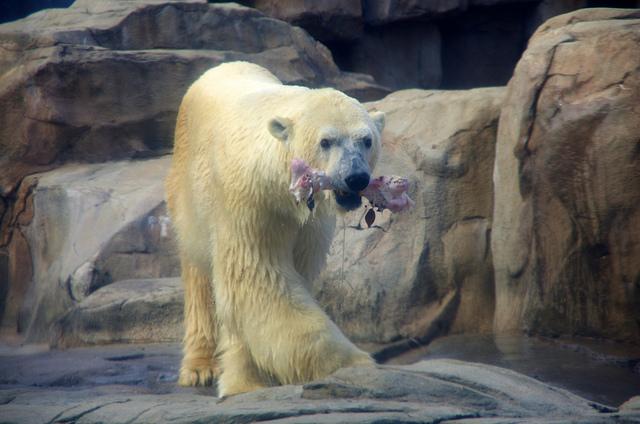Is this bear in a zoo?
Answer briefly. Yes. What is the polar bear holding?
Give a very brief answer. Bone. What type of bear is this?
Concise answer only. Polar. What is the bear carrying?
Keep it brief. Bone. What color are the rocks?
Be succinct. Brown. 